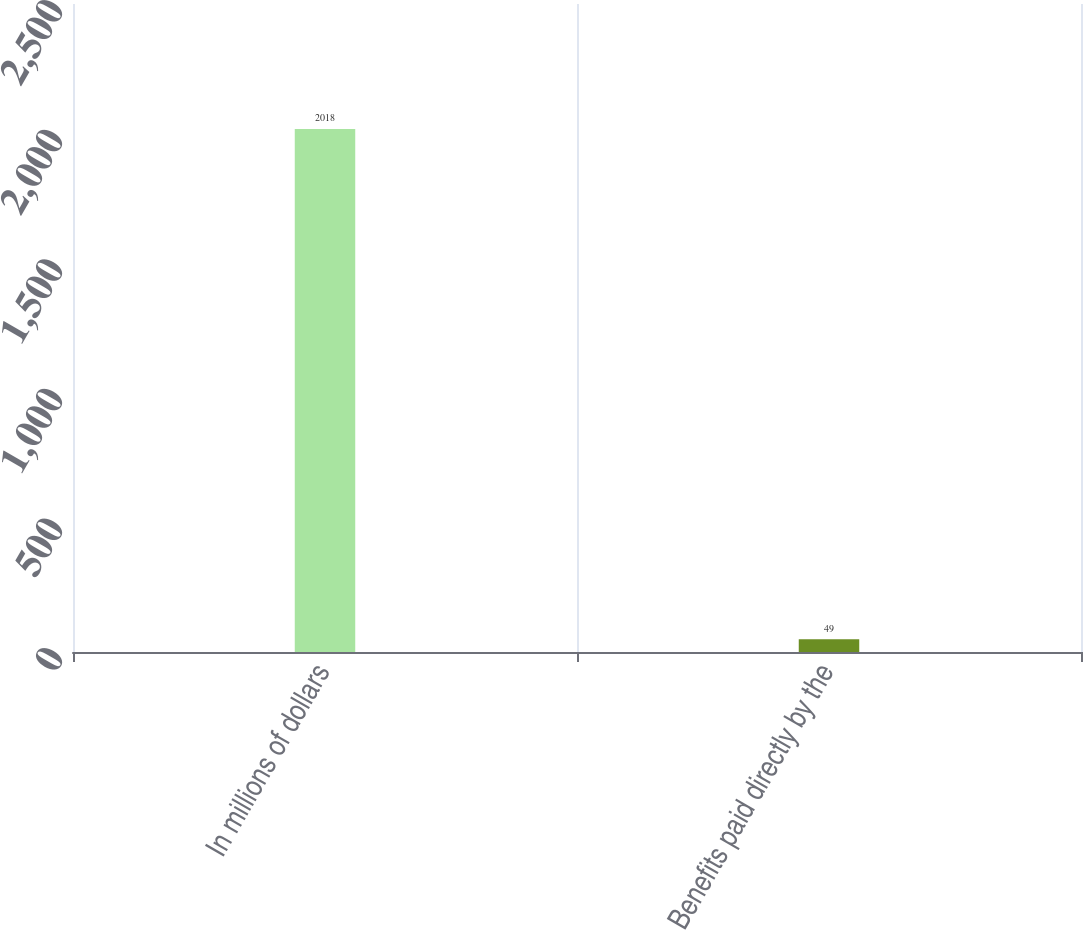Convert chart to OTSL. <chart><loc_0><loc_0><loc_500><loc_500><bar_chart><fcel>In millions of dollars<fcel>Benefits paid directly by the<nl><fcel>2018<fcel>49<nl></chart> 